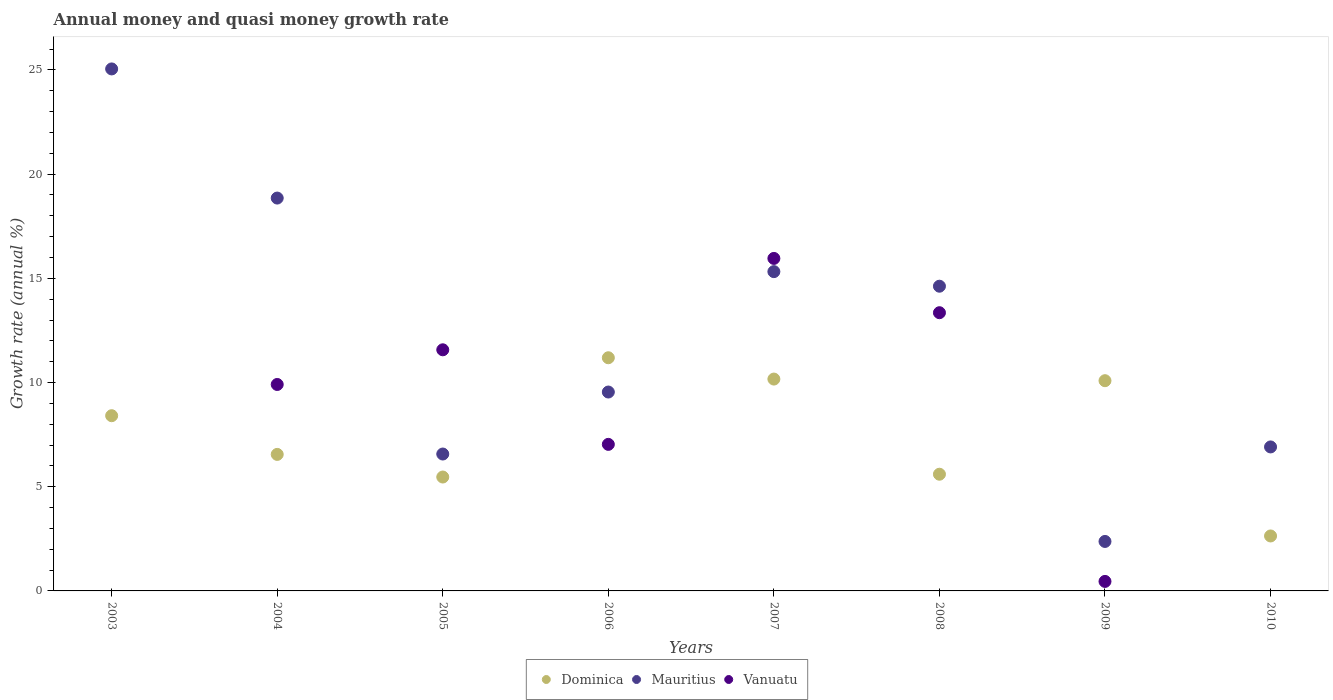What is the growth rate in Dominica in 2010?
Your answer should be compact. 2.64. Across all years, what is the maximum growth rate in Mauritius?
Give a very brief answer. 25.05. Across all years, what is the minimum growth rate in Dominica?
Make the answer very short. 2.64. In which year was the growth rate in Dominica maximum?
Make the answer very short. 2006. What is the total growth rate in Vanuatu in the graph?
Give a very brief answer. 58.28. What is the difference between the growth rate in Dominica in 2004 and that in 2006?
Offer a terse response. -4.64. What is the difference between the growth rate in Dominica in 2004 and the growth rate in Vanuatu in 2010?
Make the answer very short. 6.55. What is the average growth rate in Mauritius per year?
Keep it short and to the point. 12.41. In the year 2004, what is the difference between the growth rate in Dominica and growth rate in Mauritius?
Keep it short and to the point. -12.3. What is the ratio of the growth rate in Vanuatu in 2004 to that in 2009?
Keep it short and to the point. 21.72. Is the difference between the growth rate in Dominica in 2007 and 2010 greater than the difference between the growth rate in Mauritius in 2007 and 2010?
Keep it short and to the point. No. What is the difference between the highest and the second highest growth rate in Mauritius?
Provide a succinct answer. 6.2. What is the difference between the highest and the lowest growth rate in Dominica?
Provide a short and direct response. 8.55. In how many years, is the growth rate in Dominica greater than the average growth rate in Dominica taken over all years?
Your answer should be very brief. 4. Is the growth rate in Mauritius strictly less than the growth rate in Dominica over the years?
Your answer should be compact. No. How many years are there in the graph?
Keep it short and to the point. 8. What is the difference between two consecutive major ticks on the Y-axis?
Your answer should be very brief. 5. Does the graph contain any zero values?
Offer a very short reply. Yes. How are the legend labels stacked?
Provide a succinct answer. Horizontal. What is the title of the graph?
Your answer should be very brief. Annual money and quasi money growth rate. Does "Libya" appear as one of the legend labels in the graph?
Offer a terse response. No. What is the label or title of the X-axis?
Your answer should be very brief. Years. What is the label or title of the Y-axis?
Ensure brevity in your answer.  Growth rate (annual %). What is the Growth rate (annual %) of Dominica in 2003?
Provide a succinct answer. 8.41. What is the Growth rate (annual %) of Mauritius in 2003?
Your answer should be very brief. 25.05. What is the Growth rate (annual %) of Dominica in 2004?
Ensure brevity in your answer.  6.55. What is the Growth rate (annual %) of Mauritius in 2004?
Keep it short and to the point. 18.85. What is the Growth rate (annual %) of Vanuatu in 2004?
Provide a succinct answer. 9.91. What is the Growth rate (annual %) of Dominica in 2005?
Keep it short and to the point. 5.47. What is the Growth rate (annual %) in Mauritius in 2005?
Provide a succinct answer. 6.57. What is the Growth rate (annual %) of Vanuatu in 2005?
Provide a short and direct response. 11.57. What is the Growth rate (annual %) of Dominica in 2006?
Make the answer very short. 11.19. What is the Growth rate (annual %) in Mauritius in 2006?
Provide a succinct answer. 9.54. What is the Growth rate (annual %) of Vanuatu in 2006?
Provide a short and direct response. 7.03. What is the Growth rate (annual %) of Dominica in 2007?
Provide a short and direct response. 10.17. What is the Growth rate (annual %) in Mauritius in 2007?
Provide a short and direct response. 15.32. What is the Growth rate (annual %) of Vanuatu in 2007?
Give a very brief answer. 15.96. What is the Growth rate (annual %) of Dominica in 2008?
Offer a very short reply. 5.6. What is the Growth rate (annual %) in Mauritius in 2008?
Provide a succinct answer. 14.62. What is the Growth rate (annual %) in Vanuatu in 2008?
Offer a terse response. 13.35. What is the Growth rate (annual %) of Dominica in 2009?
Your answer should be very brief. 10.09. What is the Growth rate (annual %) of Mauritius in 2009?
Keep it short and to the point. 2.37. What is the Growth rate (annual %) of Vanuatu in 2009?
Make the answer very short. 0.46. What is the Growth rate (annual %) of Dominica in 2010?
Your answer should be compact. 2.64. What is the Growth rate (annual %) of Mauritius in 2010?
Your answer should be compact. 6.91. What is the Growth rate (annual %) of Vanuatu in 2010?
Offer a very short reply. 0. Across all years, what is the maximum Growth rate (annual %) in Dominica?
Offer a very short reply. 11.19. Across all years, what is the maximum Growth rate (annual %) of Mauritius?
Give a very brief answer. 25.05. Across all years, what is the maximum Growth rate (annual %) in Vanuatu?
Ensure brevity in your answer.  15.96. Across all years, what is the minimum Growth rate (annual %) of Dominica?
Keep it short and to the point. 2.64. Across all years, what is the minimum Growth rate (annual %) of Mauritius?
Your response must be concise. 2.37. Across all years, what is the minimum Growth rate (annual %) of Vanuatu?
Make the answer very short. 0. What is the total Growth rate (annual %) in Dominica in the graph?
Your response must be concise. 60.11. What is the total Growth rate (annual %) of Mauritius in the graph?
Your response must be concise. 99.25. What is the total Growth rate (annual %) of Vanuatu in the graph?
Provide a succinct answer. 58.28. What is the difference between the Growth rate (annual %) of Dominica in 2003 and that in 2004?
Provide a succinct answer. 1.86. What is the difference between the Growth rate (annual %) of Mauritius in 2003 and that in 2004?
Offer a terse response. 6.2. What is the difference between the Growth rate (annual %) of Dominica in 2003 and that in 2005?
Ensure brevity in your answer.  2.94. What is the difference between the Growth rate (annual %) of Mauritius in 2003 and that in 2005?
Provide a short and direct response. 18.48. What is the difference between the Growth rate (annual %) of Dominica in 2003 and that in 2006?
Keep it short and to the point. -2.78. What is the difference between the Growth rate (annual %) of Mauritius in 2003 and that in 2006?
Your answer should be very brief. 15.51. What is the difference between the Growth rate (annual %) in Dominica in 2003 and that in 2007?
Offer a terse response. -1.76. What is the difference between the Growth rate (annual %) in Mauritius in 2003 and that in 2007?
Offer a terse response. 9.73. What is the difference between the Growth rate (annual %) of Dominica in 2003 and that in 2008?
Your answer should be compact. 2.81. What is the difference between the Growth rate (annual %) of Mauritius in 2003 and that in 2008?
Offer a very short reply. 10.43. What is the difference between the Growth rate (annual %) of Dominica in 2003 and that in 2009?
Provide a short and direct response. -1.68. What is the difference between the Growth rate (annual %) in Mauritius in 2003 and that in 2009?
Keep it short and to the point. 22.68. What is the difference between the Growth rate (annual %) of Dominica in 2003 and that in 2010?
Make the answer very short. 5.77. What is the difference between the Growth rate (annual %) in Mauritius in 2003 and that in 2010?
Your answer should be compact. 18.14. What is the difference between the Growth rate (annual %) in Dominica in 2004 and that in 2005?
Provide a short and direct response. 1.09. What is the difference between the Growth rate (annual %) of Mauritius in 2004 and that in 2005?
Keep it short and to the point. 12.28. What is the difference between the Growth rate (annual %) in Vanuatu in 2004 and that in 2005?
Provide a succinct answer. -1.66. What is the difference between the Growth rate (annual %) in Dominica in 2004 and that in 2006?
Give a very brief answer. -4.64. What is the difference between the Growth rate (annual %) of Mauritius in 2004 and that in 2006?
Keep it short and to the point. 9.31. What is the difference between the Growth rate (annual %) of Vanuatu in 2004 and that in 2006?
Your response must be concise. 2.87. What is the difference between the Growth rate (annual %) of Dominica in 2004 and that in 2007?
Offer a very short reply. -3.62. What is the difference between the Growth rate (annual %) in Mauritius in 2004 and that in 2007?
Offer a terse response. 3.53. What is the difference between the Growth rate (annual %) in Vanuatu in 2004 and that in 2007?
Keep it short and to the point. -6.05. What is the difference between the Growth rate (annual %) of Dominica in 2004 and that in 2008?
Ensure brevity in your answer.  0.95. What is the difference between the Growth rate (annual %) of Mauritius in 2004 and that in 2008?
Your answer should be compact. 4.23. What is the difference between the Growth rate (annual %) of Vanuatu in 2004 and that in 2008?
Your answer should be compact. -3.44. What is the difference between the Growth rate (annual %) of Dominica in 2004 and that in 2009?
Your response must be concise. -3.54. What is the difference between the Growth rate (annual %) of Mauritius in 2004 and that in 2009?
Your answer should be compact. 16.48. What is the difference between the Growth rate (annual %) in Vanuatu in 2004 and that in 2009?
Keep it short and to the point. 9.45. What is the difference between the Growth rate (annual %) of Dominica in 2004 and that in 2010?
Make the answer very short. 3.91. What is the difference between the Growth rate (annual %) of Mauritius in 2004 and that in 2010?
Provide a succinct answer. 11.94. What is the difference between the Growth rate (annual %) in Dominica in 2005 and that in 2006?
Ensure brevity in your answer.  -5.72. What is the difference between the Growth rate (annual %) of Mauritius in 2005 and that in 2006?
Ensure brevity in your answer.  -2.98. What is the difference between the Growth rate (annual %) of Vanuatu in 2005 and that in 2006?
Give a very brief answer. 4.54. What is the difference between the Growth rate (annual %) of Dominica in 2005 and that in 2007?
Keep it short and to the point. -4.7. What is the difference between the Growth rate (annual %) of Mauritius in 2005 and that in 2007?
Offer a terse response. -8.75. What is the difference between the Growth rate (annual %) of Vanuatu in 2005 and that in 2007?
Give a very brief answer. -4.38. What is the difference between the Growth rate (annual %) in Dominica in 2005 and that in 2008?
Offer a terse response. -0.13. What is the difference between the Growth rate (annual %) in Mauritius in 2005 and that in 2008?
Offer a terse response. -8.05. What is the difference between the Growth rate (annual %) of Vanuatu in 2005 and that in 2008?
Your answer should be compact. -1.78. What is the difference between the Growth rate (annual %) in Dominica in 2005 and that in 2009?
Your answer should be compact. -4.62. What is the difference between the Growth rate (annual %) in Mauritius in 2005 and that in 2009?
Keep it short and to the point. 4.2. What is the difference between the Growth rate (annual %) in Vanuatu in 2005 and that in 2009?
Ensure brevity in your answer.  11.12. What is the difference between the Growth rate (annual %) of Dominica in 2005 and that in 2010?
Offer a terse response. 2.83. What is the difference between the Growth rate (annual %) of Mauritius in 2005 and that in 2010?
Provide a short and direct response. -0.34. What is the difference between the Growth rate (annual %) in Dominica in 2006 and that in 2007?
Keep it short and to the point. 1.02. What is the difference between the Growth rate (annual %) in Mauritius in 2006 and that in 2007?
Keep it short and to the point. -5.78. What is the difference between the Growth rate (annual %) of Vanuatu in 2006 and that in 2007?
Your answer should be compact. -8.92. What is the difference between the Growth rate (annual %) of Dominica in 2006 and that in 2008?
Keep it short and to the point. 5.59. What is the difference between the Growth rate (annual %) of Mauritius in 2006 and that in 2008?
Your answer should be compact. -5.08. What is the difference between the Growth rate (annual %) of Vanuatu in 2006 and that in 2008?
Provide a short and direct response. -6.32. What is the difference between the Growth rate (annual %) of Dominica in 2006 and that in 2009?
Your response must be concise. 1.1. What is the difference between the Growth rate (annual %) in Mauritius in 2006 and that in 2009?
Keep it short and to the point. 7.17. What is the difference between the Growth rate (annual %) in Vanuatu in 2006 and that in 2009?
Provide a succinct answer. 6.58. What is the difference between the Growth rate (annual %) in Dominica in 2006 and that in 2010?
Offer a terse response. 8.55. What is the difference between the Growth rate (annual %) of Mauritius in 2006 and that in 2010?
Your answer should be very brief. 2.63. What is the difference between the Growth rate (annual %) of Dominica in 2007 and that in 2008?
Provide a succinct answer. 4.57. What is the difference between the Growth rate (annual %) in Mauritius in 2007 and that in 2008?
Give a very brief answer. 0.7. What is the difference between the Growth rate (annual %) of Vanuatu in 2007 and that in 2008?
Provide a short and direct response. 2.61. What is the difference between the Growth rate (annual %) of Dominica in 2007 and that in 2009?
Make the answer very short. 0.08. What is the difference between the Growth rate (annual %) of Mauritius in 2007 and that in 2009?
Provide a short and direct response. 12.95. What is the difference between the Growth rate (annual %) in Vanuatu in 2007 and that in 2009?
Give a very brief answer. 15.5. What is the difference between the Growth rate (annual %) in Dominica in 2007 and that in 2010?
Your response must be concise. 7.53. What is the difference between the Growth rate (annual %) of Mauritius in 2007 and that in 2010?
Make the answer very short. 8.41. What is the difference between the Growth rate (annual %) in Dominica in 2008 and that in 2009?
Your answer should be compact. -4.49. What is the difference between the Growth rate (annual %) in Mauritius in 2008 and that in 2009?
Keep it short and to the point. 12.25. What is the difference between the Growth rate (annual %) in Vanuatu in 2008 and that in 2009?
Offer a terse response. 12.9. What is the difference between the Growth rate (annual %) of Dominica in 2008 and that in 2010?
Offer a terse response. 2.96. What is the difference between the Growth rate (annual %) of Mauritius in 2008 and that in 2010?
Provide a short and direct response. 7.71. What is the difference between the Growth rate (annual %) in Dominica in 2009 and that in 2010?
Provide a succinct answer. 7.45. What is the difference between the Growth rate (annual %) of Mauritius in 2009 and that in 2010?
Give a very brief answer. -4.54. What is the difference between the Growth rate (annual %) of Dominica in 2003 and the Growth rate (annual %) of Mauritius in 2004?
Keep it short and to the point. -10.44. What is the difference between the Growth rate (annual %) of Dominica in 2003 and the Growth rate (annual %) of Vanuatu in 2004?
Ensure brevity in your answer.  -1.5. What is the difference between the Growth rate (annual %) in Mauritius in 2003 and the Growth rate (annual %) in Vanuatu in 2004?
Your answer should be compact. 15.14. What is the difference between the Growth rate (annual %) in Dominica in 2003 and the Growth rate (annual %) in Mauritius in 2005?
Keep it short and to the point. 1.84. What is the difference between the Growth rate (annual %) of Dominica in 2003 and the Growth rate (annual %) of Vanuatu in 2005?
Offer a terse response. -3.16. What is the difference between the Growth rate (annual %) of Mauritius in 2003 and the Growth rate (annual %) of Vanuatu in 2005?
Your answer should be very brief. 13.48. What is the difference between the Growth rate (annual %) of Dominica in 2003 and the Growth rate (annual %) of Mauritius in 2006?
Ensure brevity in your answer.  -1.14. What is the difference between the Growth rate (annual %) in Dominica in 2003 and the Growth rate (annual %) in Vanuatu in 2006?
Give a very brief answer. 1.38. What is the difference between the Growth rate (annual %) in Mauritius in 2003 and the Growth rate (annual %) in Vanuatu in 2006?
Keep it short and to the point. 18.02. What is the difference between the Growth rate (annual %) of Dominica in 2003 and the Growth rate (annual %) of Mauritius in 2007?
Make the answer very short. -6.91. What is the difference between the Growth rate (annual %) in Dominica in 2003 and the Growth rate (annual %) in Vanuatu in 2007?
Offer a terse response. -7.55. What is the difference between the Growth rate (annual %) of Mauritius in 2003 and the Growth rate (annual %) of Vanuatu in 2007?
Offer a terse response. 9.09. What is the difference between the Growth rate (annual %) of Dominica in 2003 and the Growth rate (annual %) of Mauritius in 2008?
Provide a short and direct response. -6.21. What is the difference between the Growth rate (annual %) of Dominica in 2003 and the Growth rate (annual %) of Vanuatu in 2008?
Provide a short and direct response. -4.94. What is the difference between the Growth rate (annual %) of Mauritius in 2003 and the Growth rate (annual %) of Vanuatu in 2008?
Your answer should be very brief. 11.7. What is the difference between the Growth rate (annual %) of Dominica in 2003 and the Growth rate (annual %) of Mauritius in 2009?
Offer a terse response. 6.03. What is the difference between the Growth rate (annual %) in Dominica in 2003 and the Growth rate (annual %) in Vanuatu in 2009?
Make the answer very short. 7.95. What is the difference between the Growth rate (annual %) in Mauritius in 2003 and the Growth rate (annual %) in Vanuatu in 2009?
Provide a succinct answer. 24.59. What is the difference between the Growth rate (annual %) in Dominica in 2003 and the Growth rate (annual %) in Mauritius in 2010?
Your response must be concise. 1.5. What is the difference between the Growth rate (annual %) of Dominica in 2004 and the Growth rate (annual %) of Mauritius in 2005?
Provide a short and direct response. -0.02. What is the difference between the Growth rate (annual %) in Dominica in 2004 and the Growth rate (annual %) in Vanuatu in 2005?
Ensure brevity in your answer.  -5.02. What is the difference between the Growth rate (annual %) of Mauritius in 2004 and the Growth rate (annual %) of Vanuatu in 2005?
Your answer should be very brief. 7.28. What is the difference between the Growth rate (annual %) of Dominica in 2004 and the Growth rate (annual %) of Mauritius in 2006?
Your answer should be compact. -2.99. What is the difference between the Growth rate (annual %) in Dominica in 2004 and the Growth rate (annual %) in Vanuatu in 2006?
Offer a very short reply. -0.48. What is the difference between the Growth rate (annual %) in Mauritius in 2004 and the Growth rate (annual %) in Vanuatu in 2006?
Your response must be concise. 11.82. What is the difference between the Growth rate (annual %) in Dominica in 2004 and the Growth rate (annual %) in Mauritius in 2007?
Give a very brief answer. -8.77. What is the difference between the Growth rate (annual %) of Dominica in 2004 and the Growth rate (annual %) of Vanuatu in 2007?
Give a very brief answer. -9.4. What is the difference between the Growth rate (annual %) of Mauritius in 2004 and the Growth rate (annual %) of Vanuatu in 2007?
Keep it short and to the point. 2.9. What is the difference between the Growth rate (annual %) of Dominica in 2004 and the Growth rate (annual %) of Mauritius in 2008?
Provide a succinct answer. -8.07. What is the difference between the Growth rate (annual %) in Dominica in 2004 and the Growth rate (annual %) in Vanuatu in 2008?
Provide a short and direct response. -6.8. What is the difference between the Growth rate (annual %) in Mauritius in 2004 and the Growth rate (annual %) in Vanuatu in 2008?
Provide a short and direct response. 5.5. What is the difference between the Growth rate (annual %) of Dominica in 2004 and the Growth rate (annual %) of Mauritius in 2009?
Make the answer very short. 4.18. What is the difference between the Growth rate (annual %) of Dominica in 2004 and the Growth rate (annual %) of Vanuatu in 2009?
Give a very brief answer. 6.1. What is the difference between the Growth rate (annual %) in Mauritius in 2004 and the Growth rate (annual %) in Vanuatu in 2009?
Your answer should be very brief. 18.4. What is the difference between the Growth rate (annual %) of Dominica in 2004 and the Growth rate (annual %) of Mauritius in 2010?
Offer a terse response. -0.36. What is the difference between the Growth rate (annual %) in Dominica in 2005 and the Growth rate (annual %) in Mauritius in 2006?
Offer a terse response. -4.08. What is the difference between the Growth rate (annual %) of Dominica in 2005 and the Growth rate (annual %) of Vanuatu in 2006?
Your answer should be very brief. -1.57. What is the difference between the Growth rate (annual %) of Mauritius in 2005 and the Growth rate (annual %) of Vanuatu in 2006?
Provide a succinct answer. -0.46. What is the difference between the Growth rate (annual %) in Dominica in 2005 and the Growth rate (annual %) in Mauritius in 2007?
Make the answer very short. -9.86. What is the difference between the Growth rate (annual %) in Dominica in 2005 and the Growth rate (annual %) in Vanuatu in 2007?
Ensure brevity in your answer.  -10.49. What is the difference between the Growth rate (annual %) in Mauritius in 2005 and the Growth rate (annual %) in Vanuatu in 2007?
Your answer should be compact. -9.39. What is the difference between the Growth rate (annual %) of Dominica in 2005 and the Growth rate (annual %) of Mauritius in 2008?
Give a very brief answer. -9.16. What is the difference between the Growth rate (annual %) in Dominica in 2005 and the Growth rate (annual %) in Vanuatu in 2008?
Keep it short and to the point. -7.89. What is the difference between the Growth rate (annual %) in Mauritius in 2005 and the Growth rate (annual %) in Vanuatu in 2008?
Provide a succinct answer. -6.78. What is the difference between the Growth rate (annual %) in Dominica in 2005 and the Growth rate (annual %) in Mauritius in 2009?
Ensure brevity in your answer.  3.09. What is the difference between the Growth rate (annual %) of Dominica in 2005 and the Growth rate (annual %) of Vanuatu in 2009?
Offer a very short reply. 5.01. What is the difference between the Growth rate (annual %) of Mauritius in 2005 and the Growth rate (annual %) of Vanuatu in 2009?
Offer a terse response. 6.11. What is the difference between the Growth rate (annual %) of Dominica in 2005 and the Growth rate (annual %) of Mauritius in 2010?
Provide a succinct answer. -1.44. What is the difference between the Growth rate (annual %) of Dominica in 2006 and the Growth rate (annual %) of Mauritius in 2007?
Provide a short and direct response. -4.13. What is the difference between the Growth rate (annual %) of Dominica in 2006 and the Growth rate (annual %) of Vanuatu in 2007?
Provide a short and direct response. -4.77. What is the difference between the Growth rate (annual %) in Mauritius in 2006 and the Growth rate (annual %) in Vanuatu in 2007?
Give a very brief answer. -6.41. What is the difference between the Growth rate (annual %) in Dominica in 2006 and the Growth rate (annual %) in Mauritius in 2008?
Offer a very short reply. -3.43. What is the difference between the Growth rate (annual %) in Dominica in 2006 and the Growth rate (annual %) in Vanuatu in 2008?
Keep it short and to the point. -2.16. What is the difference between the Growth rate (annual %) in Mauritius in 2006 and the Growth rate (annual %) in Vanuatu in 2008?
Your answer should be very brief. -3.81. What is the difference between the Growth rate (annual %) of Dominica in 2006 and the Growth rate (annual %) of Mauritius in 2009?
Give a very brief answer. 8.82. What is the difference between the Growth rate (annual %) of Dominica in 2006 and the Growth rate (annual %) of Vanuatu in 2009?
Offer a very short reply. 10.73. What is the difference between the Growth rate (annual %) in Mauritius in 2006 and the Growth rate (annual %) in Vanuatu in 2009?
Provide a short and direct response. 9.09. What is the difference between the Growth rate (annual %) in Dominica in 2006 and the Growth rate (annual %) in Mauritius in 2010?
Keep it short and to the point. 4.28. What is the difference between the Growth rate (annual %) of Dominica in 2007 and the Growth rate (annual %) of Mauritius in 2008?
Your response must be concise. -4.46. What is the difference between the Growth rate (annual %) in Dominica in 2007 and the Growth rate (annual %) in Vanuatu in 2008?
Your answer should be very brief. -3.18. What is the difference between the Growth rate (annual %) in Mauritius in 2007 and the Growth rate (annual %) in Vanuatu in 2008?
Provide a succinct answer. 1.97. What is the difference between the Growth rate (annual %) in Dominica in 2007 and the Growth rate (annual %) in Mauritius in 2009?
Provide a succinct answer. 7.79. What is the difference between the Growth rate (annual %) in Dominica in 2007 and the Growth rate (annual %) in Vanuatu in 2009?
Your response must be concise. 9.71. What is the difference between the Growth rate (annual %) in Mauritius in 2007 and the Growth rate (annual %) in Vanuatu in 2009?
Your answer should be very brief. 14.87. What is the difference between the Growth rate (annual %) of Dominica in 2007 and the Growth rate (annual %) of Mauritius in 2010?
Provide a short and direct response. 3.26. What is the difference between the Growth rate (annual %) of Dominica in 2008 and the Growth rate (annual %) of Mauritius in 2009?
Keep it short and to the point. 3.23. What is the difference between the Growth rate (annual %) of Dominica in 2008 and the Growth rate (annual %) of Vanuatu in 2009?
Give a very brief answer. 5.14. What is the difference between the Growth rate (annual %) of Mauritius in 2008 and the Growth rate (annual %) of Vanuatu in 2009?
Ensure brevity in your answer.  14.17. What is the difference between the Growth rate (annual %) of Dominica in 2008 and the Growth rate (annual %) of Mauritius in 2010?
Give a very brief answer. -1.31. What is the difference between the Growth rate (annual %) of Dominica in 2009 and the Growth rate (annual %) of Mauritius in 2010?
Your response must be concise. 3.18. What is the average Growth rate (annual %) in Dominica per year?
Keep it short and to the point. 7.51. What is the average Growth rate (annual %) in Mauritius per year?
Make the answer very short. 12.41. What is the average Growth rate (annual %) in Vanuatu per year?
Your answer should be very brief. 7.28. In the year 2003, what is the difference between the Growth rate (annual %) of Dominica and Growth rate (annual %) of Mauritius?
Provide a short and direct response. -16.64. In the year 2004, what is the difference between the Growth rate (annual %) of Dominica and Growth rate (annual %) of Mauritius?
Provide a short and direct response. -12.3. In the year 2004, what is the difference between the Growth rate (annual %) of Dominica and Growth rate (annual %) of Vanuatu?
Your answer should be very brief. -3.36. In the year 2004, what is the difference between the Growth rate (annual %) in Mauritius and Growth rate (annual %) in Vanuatu?
Your answer should be very brief. 8.95. In the year 2005, what is the difference between the Growth rate (annual %) in Dominica and Growth rate (annual %) in Mauritius?
Ensure brevity in your answer.  -1.1. In the year 2005, what is the difference between the Growth rate (annual %) of Dominica and Growth rate (annual %) of Vanuatu?
Offer a very short reply. -6.11. In the year 2005, what is the difference between the Growth rate (annual %) of Mauritius and Growth rate (annual %) of Vanuatu?
Your response must be concise. -5. In the year 2006, what is the difference between the Growth rate (annual %) of Dominica and Growth rate (annual %) of Mauritius?
Your answer should be compact. 1.65. In the year 2006, what is the difference between the Growth rate (annual %) of Dominica and Growth rate (annual %) of Vanuatu?
Your answer should be compact. 4.16. In the year 2006, what is the difference between the Growth rate (annual %) in Mauritius and Growth rate (annual %) in Vanuatu?
Offer a terse response. 2.51. In the year 2007, what is the difference between the Growth rate (annual %) of Dominica and Growth rate (annual %) of Mauritius?
Your answer should be very brief. -5.16. In the year 2007, what is the difference between the Growth rate (annual %) in Dominica and Growth rate (annual %) in Vanuatu?
Your response must be concise. -5.79. In the year 2007, what is the difference between the Growth rate (annual %) of Mauritius and Growth rate (annual %) of Vanuatu?
Your answer should be very brief. -0.63. In the year 2008, what is the difference between the Growth rate (annual %) of Dominica and Growth rate (annual %) of Mauritius?
Give a very brief answer. -9.02. In the year 2008, what is the difference between the Growth rate (annual %) of Dominica and Growth rate (annual %) of Vanuatu?
Offer a terse response. -7.75. In the year 2008, what is the difference between the Growth rate (annual %) of Mauritius and Growth rate (annual %) of Vanuatu?
Offer a very short reply. 1.27. In the year 2009, what is the difference between the Growth rate (annual %) in Dominica and Growth rate (annual %) in Mauritius?
Your answer should be very brief. 7.71. In the year 2009, what is the difference between the Growth rate (annual %) in Dominica and Growth rate (annual %) in Vanuatu?
Offer a very short reply. 9.63. In the year 2009, what is the difference between the Growth rate (annual %) in Mauritius and Growth rate (annual %) in Vanuatu?
Your response must be concise. 1.92. In the year 2010, what is the difference between the Growth rate (annual %) in Dominica and Growth rate (annual %) in Mauritius?
Provide a short and direct response. -4.27. What is the ratio of the Growth rate (annual %) in Dominica in 2003 to that in 2004?
Give a very brief answer. 1.28. What is the ratio of the Growth rate (annual %) in Mauritius in 2003 to that in 2004?
Your answer should be very brief. 1.33. What is the ratio of the Growth rate (annual %) of Dominica in 2003 to that in 2005?
Offer a terse response. 1.54. What is the ratio of the Growth rate (annual %) in Mauritius in 2003 to that in 2005?
Keep it short and to the point. 3.81. What is the ratio of the Growth rate (annual %) in Dominica in 2003 to that in 2006?
Your answer should be compact. 0.75. What is the ratio of the Growth rate (annual %) of Mauritius in 2003 to that in 2006?
Provide a succinct answer. 2.62. What is the ratio of the Growth rate (annual %) of Dominica in 2003 to that in 2007?
Make the answer very short. 0.83. What is the ratio of the Growth rate (annual %) of Mauritius in 2003 to that in 2007?
Your answer should be very brief. 1.63. What is the ratio of the Growth rate (annual %) in Dominica in 2003 to that in 2008?
Keep it short and to the point. 1.5. What is the ratio of the Growth rate (annual %) in Mauritius in 2003 to that in 2008?
Your answer should be compact. 1.71. What is the ratio of the Growth rate (annual %) in Dominica in 2003 to that in 2009?
Your response must be concise. 0.83. What is the ratio of the Growth rate (annual %) in Mauritius in 2003 to that in 2009?
Keep it short and to the point. 10.55. What is the ratio of the Growth rate (annual %) in Dominica in 2003 to that in 2010?
Give a very brief answer. 3.19. What is the ratio of the Growth rate (annual %) of Mauritius in 2003 to that in 2010?
Offer a very short reply. 3.63. What is the ratio of the Growth rate (annual %) of Dominica in 2004 to that in 2005?
Provide a succinct answer. 1.2. What is the ratio of the Growth rate (annual %) in Mauritius in 2004 to that in 2005?
Make the answer very short. 2.87. What is the ratio of the Growth rate (annual %) in Vanuatu in 2004 to that in 2005?
Ensure brevity in your answer.  0.86. What is the ratio of the Growth rate (annual %) in Dominica in 2004 to that in 2006?
Provide a succinct answer. 0.59. What is the ratio of the Growth rate (annual %) of Mauritius in 2004 to that in 2006?
Keep it short and to the point. 1.98. What is the ratio of the Growth rate (annual %) in Vanuatu in 2004 to that in 2006?
Give a very brief answer. 1.41. What is the ratio of the Growth rate (annual %) in Dominica in 2004 to that in 2007?
Your answer should be compact. 0.64. What is the ratio of the Growth rate (annual %) of Mauritius in 2004 to that in 2007?
Your answer should be compact. 1.23. What is the ratio of the Growth rate (annual %) in Vanuatu in 2004 to that in 2007?
Your answer should be very brief. 0.62. What is the ratio of the Growth rate (annual %) in Dominica in 2004 to that in 2008?
Give a very brief answer. 1.17. What is the ratio of the Growth rate (annual %) in Mauritius in 2004 to that in 2008?
Provide a succinct answer. 1.29. What is the ratio of the Growth rate (annual %) of Vanuatu in 2004 to that in 2008?
Ensure brevity in your answer.  0.74. What is the ratio of the Growth rate (annual %) in Dominica in 2004 to that in 2009?
Your answer should be compact. 0.65. What is the ratio of the Growth rate (annual %) in Mauritius in 2004 to that in 2009?
Keep it short and to the point. 7.94. What is the ratio of the Growth rate (annual %) in Vanuatu in 2004 to that in 2009?
Give a very brief answer. 21.72. What is the ratio of the Growth rate (annual %) of Dominica in 2004 to that in 2010?
Offer a very short reply. 2.48. What is the ratio of the Growth rate (annual %) of Mauritius in 2004 to that in 2010?
Provide a succinct answer. 2.73. What is the ratio of the Growth rate (annual %) in Dominica in 2005 to that in 2006?
Keep it short and to the point. 0.49. What is the ratio of the Growth rate (annual %) of Mauritius in 2005 to that in 2006?
Give a very brief answer. 0.69. What is the ratio of the Growth rate (annual %) of Vanuatu in 2005 to that in 2006?
Make the answer very short. 1.65. What is the ratio of the Growth rate (annual %) in Dominica in 2005 to that in 2007?
Offer a very short reply. 0.54. What is the ratio of the Growth rate (annual %) of Mauritius in 2005 to that in 2007?
Offer a very short reply. 0.43. What is the ratio of the Growth rate (annual %) of Vanuatu in 2005 to that in 2007?
Offer a terse response. 0.73. What is the ratio of the Growth rate (annual %) in Dominica in 2005 to that in 2008?
Keep it short and to the point. 0.98. What is the ratio of the Growth rate (annual %) of Mauritius in 2005 to that in 2008?
Give a very brief answer. 0.45. What is the ratio of the Growth rate (annual %) of Vanuatu in 2005 to that in 2008?
Provide a succinct answer. 0.87. What is the ratio of the Growth rate (annual %) in Dominica in 2005 to that in 2009?
Provide a succinct answer. 0.54. What is the ratio of the Growth rate (annual %) of Mauritius in 2005 to that in 2009?
Provide a succinct answer. 2.77. What is the ratio of the Growth rate (annual %) in Vanuatu in 2005 to that in 2009?
Give a very brief answer. 25.37. What is the ratio of the Growth rate (annual %) in Dominica in 2005 to that in 2010?
Give a very brief answer. 2.07. What is the ratio of the Growth rate (annual %) of Mauritius in 2005 to that in 2010?
Offer a very short reply. 0.95. What is the ratio of the Growth rate (annual %) of Dominica in 2006 to that in 2007?
Your answer should be very brief. 1.1. What is the ratio of the Growth rate (annual %) of Mauritius in 2006 to that in 2007?
Your answer should be very brief. 0.62. What is the ratio of the Growth rate (annual %) in Vanuatu in 2006 to that in 2007?
Ensure brevity in your answer.  0.44. What is the ratio of the Growth rate (annual %) of Dominica in 2006 to that in 2008?
Keep it short and to the point. 2. What is the ratio of the Growth rate (annual %) in Mauritius in 2006 to that in 2008?
Make the answer very short. 0.65. What is the ratio of the Growth rate (annual %) of Vanuatu in 2006 to that in 2008?
Your response must be concise. 0.53. What is the ratio of the Growth rate (annual %) in Dominica in 2006 to that in 2009?
Keep it short and to the point. 1.11. What is the ratio of the Growth rate (annual %) in Mauritius in 2006 to that in 2009?
Give a very brief answer. 4.02. What is the ratio of the Growth rate (annual %) in Vanuatu in 2006 to that in 2009?
Your answer should be very brief. 15.42. What is the ratio of the Growth rate (annual %) in Dominica in 2006 to that in 2010?
Your answer should be compact. 4.24. What is the ratio of the Growth rate (annual %) of Mauritius in 2006 to that in 2010?
Give a very brief answer. 1.38. What is the ratio of the Growth rate (annual %) in Dominica in 2007 to that in 2008?
Offer a terse response. 1.82. What is the ratio of the Growth rate (annual %) in Mauritius in 2007 to that in 2008?
Your response must be concise. 1.05. What is the ratio of the Growth rate (annual %) in Vanuatu in 2007 to that in 2008?
Provide a succinct answer. 1.2. What is the ratio of the Growth rate (annual %) in Dominica in 2007 to that in 2009?
Keep it short and to the point. 1.01. What is the ratio of the Growth rate (annual %) in Mauritius in 2007 to that in 2009?
Make the answer very short. 6.45. What is the ratio of the Growth rate (annual %) of Vanuatu in 2007 to that in 2009?
Keep it short and to the point. 34.99. What is the ratio of the Growth rate (annual %) in Dominica in 2007 to that in 2010?
Keep it short and to the point. 3.85. What is the ratio of the Growth rate (annual %) in Mauritius in 2007 to that in 2010?
Give a very brief answer. 2.22. What is the ratio of the Growth rate (annual %) of Dominica in 2008 to that in 2009?
Offer a terse response. 0.56. What is the ratio of the Growth rate (annual %) of Mauritius in 2008 to that in 2009?
Your answer should be compact. 6.16. What is the ratio of the Growth rate (annual %) in Vanuatu in 2008 to that in 2009?
Your response must be concise. 29.27. What is the ratio of the Growth rate (annual %) in Dominica in 2008 to that in 2010?
Keep it short and to the point. 2.12. What is the ratio of the Growth rate (annual %) of Mauritius in 2008 to that in 2010?
Offer a very short reply. 2.12. What is the ratio of the Growth rate (annual %) in Dominica in 2009 to that in 2010?
Keep it short and to the point. 3.83. What is the ratio of the Growth rate (annual %) of Mauritius in 2009 to that in 2010?
Make the answer very short. 0.34. What is the difference between the highest and the second highest Growth rate (annual %) in Dominica?
Provide a succinct answer. 1.02. What is the difference between the highest and the second highest Growth rate (annual %) of Mauritius?
Provide a short and direct response. 6.2. What is the difference between the highest and the second highest Growth rate (annual %) in Vanuatu?
Provide a short and direct response. 2.61. What is the difference between the highest and the lowest Growth rate (annual %) in Dominica?
Provide a succinct answer. 8.55. What is the difference between the highest and the lowest Growth rate (annual %) of Mauritius?
Offer a terse response. 22.68. What is the difference between the highest and the lowest Growth rate (annual %) of Vanuatu?
Your answer should be very brief. 15.96. 